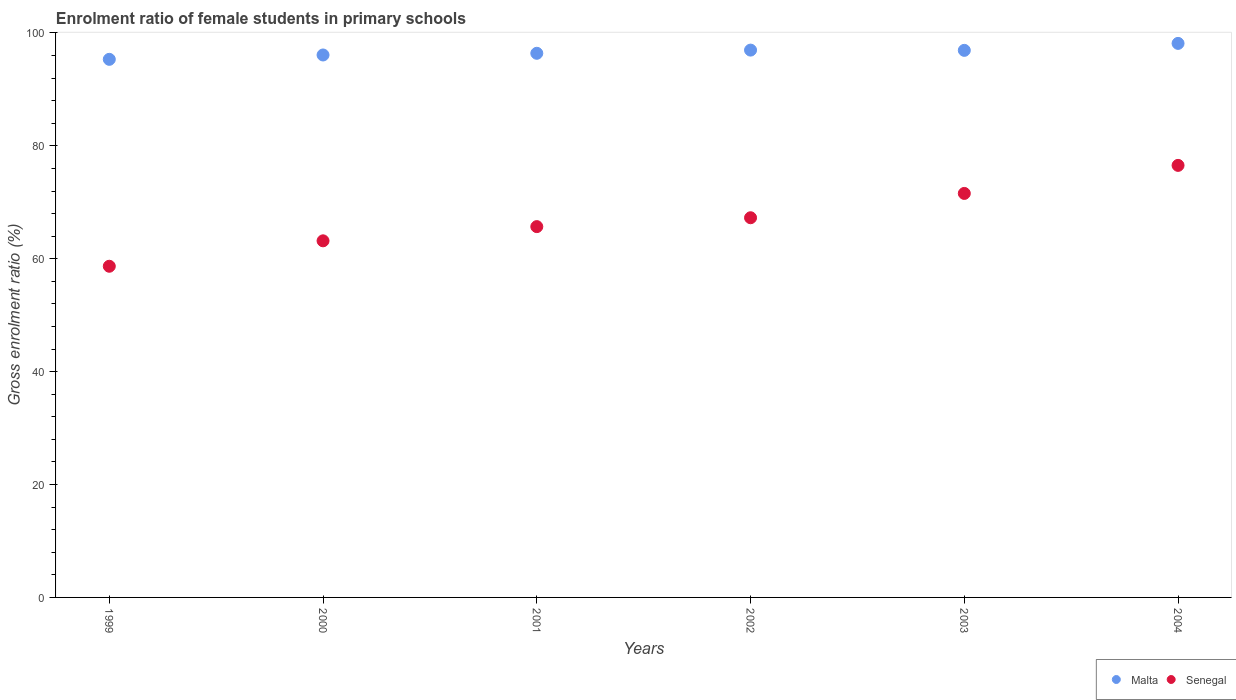Is the number of dotlines equal to the number of legend labels?
Your response must be concise. Yes. What is the enrolment ratio of female students in primary schools in Malta in 2002?
Your answer should be very brief. 96.96. Across all years, what is the maximum enrolment ratio of female students in primary schools in Malta?
Ensure brevity in your answer.  98.15. Across all years, what is the minimum enrolment ratio of female students in primary schools in Malta?
Ensure brevity in your answer.  95.33. In which year was the enrolment ratio of female students in primary schools in Malta minimum?
Offer a terse response. 1999. What is the total enrolment ratio of female students in primary schools in Malta in the graph?
Provide a succinct answer. 579.86. What is the difference between the enrolment ratio of female students in primary schools in Malta in 2002 and that in 2003?
Your response must be concise. 0.04. What is the difference between the enrolment ratio of female students in primary schools in Senegal in 2004 and the enrolment ratio of female students in primary schools in Malta in 1999?
Your answer should be very brief. -18.79. What is the average enrolment ratio of female students in primary schools in Senegal per year?
Provide a short and direct response. 67.15. In the year 2001, what is the difference between the enrolment ratio of female students in primary schools in Malta and enrolment ratio of female students in primary schools in Senegal?
Ensure brevity in your answer.  30.71. What is the ratio of the enrolment ratio of female students in primary schools in Senegal in 2002 to that in 2004?
Your answer should be very brief. 0.88. What is the difference between the highest and the second highest enrolment ratio of female students in primary schools in Malta?
Provide a short and direct response. 1.19. What is the difference between the highest and the lowest enrolment ratio of female students in primary schools in Malta?
Provide a short and direct response. 2.82. Is the sum of the enrolment ratio of female students in primary schools in Senegal in 1999 and 2002 greater than the maximum enrolment ratio of female students in primary schools in Malta across all years?
Ensure brevity in your answer.  Yes. Does the enrolment ratio of female students in primary schools in Senegal monotonically increase over the years?
Keep it short and to the point. Yes. Is the enrolment ratio of female students in primary schools in Senegal strictly less than the enrolment ratio of female students in primary schools in Malta over the years?
Give a very brief answer. Yes. How many years are there in the graph?
Make the answer very short. 6. Does the graph contain any zero values?
Give a very brief answer. No. Does the graph contain grids?
Offer a very short reply. No. Where does the legend appear in the graph?
Make the answer very short. Bottom right. How many legend labels are there?
Your response must be concise. 2. How are the legend labels stacked?
Provide a short and direct response. Horizontal. What is the title of the graph?
Keep it short and to the point. Enrolment ratio of female students in primary schools. Does "French Polynesia" appear as one of the legend labels in the graph?
Give a very brief answer. No. What is the label or title of the X-axis?
Keep it short and to the point. Years. What is the label or title of the Y-axis?
Your response must be concise. Gross enrolment ratio (%). What is the Gross enrolment ratio (%) of Malta in 1999?
Give a very brief answer. 95.33. What is the Gross enrolment ratio (%) in Senegal in 1999?
Give a very brief answer. 58.67. What is the Gross enrolment ratio (%) in Malta in 2000?
Your answer should be compact. 96.1. What is the Gross enrolment ratio (%) in Senegal in 2000?
Provide a short and direct response. 63.17. What is the Gross enrolment ratio (%) in Malta in 2001?
Make the answer very short. 96.4. What is the Gross enrolment ratio (%) of Senegal in 2001?
Keep it short and to the point. 65.69. What is the Gross enrolment ratio (%) of Malta in 2002?
Your answer should be very brief. 96.96. What is the Gross enrolment ratio (%) of Senegal in 2002?
Your response must be concise. 67.26. What is the Gross enrolment ratio (%) of Malta in 2003?
Your answer should be compact. 96.92. What is the Gross enrolment ratio (%) in Senegal in 2003?
Your response must be concise. 71.57. What is the Gross enrolment ratio (%) in Malta in 2004?
Offer a terse response. 98.15. What is the Gross enrolment ratio (%) in Senegal in 2004?
Keep it short and to the point. 76.54. Across all years, what is the maximum Gross enrolment ratio (%) in Malta?
Give a very brief answer. 98.15. Across all years, what is the maximum Gross enrolment ratio (%) in Senegal?
Provide a short and direct response. 76.54. Across all years, what is the minimum Gross enrolment ratio (%) of Malta?
Provide a short and direct response. 95.33. Across all years, what is the minimum Gross enrolment ratio (%) in Senegal?
Make the answer very short. 58.67. What is the total Gross enrolment ratio (%) of Malta in the graph?
Keep it short and to the point. 579.86. What is the total Gross enrolment ratio (%) of Senegal in the graph?
Make the answer very short. 402.91. What is the difference between the Gross enrolment ratio (%) of Malta in 1999 and that in 2000?
Ensure brevity in your answer.  -0.77. What is the difference between the Gross enrolment ratio (%) in Senegal in 1999 and that in 2000?
Your answer should be compact. -4.5. What is the difference between the Gross enrolment ratio (%) of Malta in 1999 and that in 2001?
Ensure brevity in your answer.  -1.07. What is the difference between the Gross enrolment ratio (%) in Senegal in 1999 and that in 2001?
Keep it short and to the point. -7.02. What is the difference between the Gross enrolment ratio (%) of Malta in 1999 and that in 2002?
Ensure brevity in your answer.  -1.63. What is the difference between the Gross enrolment ratio (%) in Senegal in 1999 and that in 2002?
Give a very brief answer. -8.59. What is the difference between the Gross enrolment ratio (%) in Malta in 1999 and that in 2003?
Provide a short and direct response. -1.59. What is the difference between the Gross enrolment ratio (%) of Senegal in 1999 and that in 2003?
Your answer should be compact. -12.9. What is the difference between the Gross enrolment ratio (%) in Malta in 1999 and that in 2004?
Your response must be concise. -2.82. What is the difference between the Gross enrolment ratio (%) in Senegal in 1999 and that in 2004?
Keep it short and to the point. -17.87. What is the difference between the Gross enrolment ratio (%) of Malta in 2000 and that in 2001?
Offer a very short reply. -0.3. What is the difference between the Gross enrolment ratio (%) of Senegal in 2000 and that in 2001?
Your answer should be compact. -2.52. What is the difference between the Gross enrolment ratio (%) of Malta in 2000 and that in 2002?
Provide a short and direct response. -0.86. What is the difference between the Gross enrolment ratio (%) in Senegal in 2000 and that in 2002?
Provide a short and direct response. -4.09. What is the difference between the Gross enrolment ratio (%) of Malta in 2000 and that in 2003?
Offer a terse response. -0.82. What is the difference between the Gross enrolment ratio (%) of Senegal in 2000 and that in 2003?
Provide a succinct answer. -8.4. What is the difference between the Gross enrolment ratio (%) of Malta in 2000 and that in 2004?
Offer a very short reply. -2.05. What is the difference between the Gross enrolment ratio (%) of Senegal in 2000 and that in 2004?
Make the answer very short. -13.37. What is the difference between the Gross enrolment ratio (%) of Malta in 2001 and that in 2002?
Provide a short and direct response. -0.56. What is the difference between the Gross enrolment ratio (%) in Senegal in 2001 and that in 2002?
Provide a short and direct response. -1.57. What is the difference between the Gross enrolment ratio (%) of Malta in 2001 and that in 2003?
Your answer should be compact. -0.52. What is the difference between the Gross enrolment ratio (%) of Senegal in 2001 and that in 2003?
Make the answer very short. -5.88. What is the difference between the Gross enrolment ratio (%) of Malta in 2001 and that in 2004?
Offer a very short reply. -1.75. What is the difference between the Gross enrolment ratio (%) in Senegal in 2001 and that in 2004?
Your answer should be compact. -10.85. What is the difference between the Gross enrolment ratio (%) in Malta in 2002 and that in 2003?
Your answer should be compact. 0.04. What is the difference between the Gross enrolment ratio (%) in Senegal in 2002 and that in 2003?
Your answer should be very brief. -4.31. What is the difference between the Gross enrolment ratio (%) in Malta in 2002 and that in 2004?
Your answer should be compact. -1.19. What is the difference between the Gross enrolment ratio (%) in Senegal in 2002 and that in 2004?
Offer a very short reply. -9.28. What is the difference between the Gross enrolment ratio (%) of Malta in 2003 and that in 2004?
Offer a very short reply. -1.23. What is the difference between the Gross enrolment ratio (%) of Senegal in 2003 and that in 2004?
Keep it short and to the point. -4.97. What is the difference between the Gross enrolment ratio (%) of Malta in 1999 and the Gross enrolment ratio (%) of Senegal in 2000?
Your response must be concise. 32.15. What is the difference between the Gross enrolment ratio (%) in Malta in 1999 and the Gross enrolment ratio (%) in Senegal in 2001?
Offer a very short reply. 29.64. What is the difference between the Gross enrolment ratio (%) in Malta in 1999 and the Gross enrolment ratio (%) in Senegal in 2002?
Give a very brief answer. 28.06. What is the difference between the Gross enrolment ratio (%) in Malta in 1999 and the Gross enrolment ratio (%) in Senegal in 2003?
Make the answer very short. 23.76. What is the difference between the Gross enrolment ratio (%) of Malta in 1999 and the Gross enrolment ratio (%) of Senegal in 2004?
Provide a succinct answer. 18.79. What is the difference between the Gross enrolment ratio (%) in Malta in 2000 and the Gross enrolment ratio (%) in Senegal in 2001?
Keep it short and to the point. 30.41. What is the difference between the Gross enrolment ratio (%) of Malta in 2000 and the Gross enrolment ratio (%) of Senegal in 2002?
Offer a terse response. 28.84. What is the difference between the Gross enrolment ratio (%) in Malta in 2000 and the Gross enrolment ratio (%) in Senegal in 2003?
Offer a terse response. 24.53. What is the difference between the Gross enrolment ratio (%) of Malta in 2000 and the Gross enrolment ratio (%) of Senegal in 2004?
Your answer should be very brief. 19.56. What is the difference between the Gross enrolment ratio (%) of Malta in 2001 and the Gross enrolment ratio (%) of Senegal in 2002?
Keep it short and to the point. 29.14. What is the difference between the Gross enrolment ratio (%) of Malta in 2001 and the Gross enrolment ratio (%) of Senegal in 2003?
Keep it short and to the point. 24.83. What is the difference between the Gross enrolment ratio (%) in Malta in 2001 and the Gross enrolment ratio (%) in Senegal in 2004?
Make the answer very short. 19.86. What is the difference between the Gross enrolment ratio (%) in Malta in 2002 and the Gross enrolment ratio (%) in Senegal in 2003?
Offer a very short reply. 25.39. What is the difference between the Gross enrolment ratio (%) of Malta in 2002 and the Gross enrolment ratio (%) of Senegal in 2004?
Offer a terse response. 20.42. What is the difference between the Gross enrolment ratio (%) of Malta in 2003 and the Gross enrolment ratio (%) of Senegal in 2004?
Keep it short and to the point. 20.38. What is the average Gross enrolment ratio (%) in Malta per year?
Provide a short and direct response. 96.64. What is the average Gross enrolment ratio (%) in Senegal per year?
Offer a terse response. 67.15. In the year 1999, what is the difference between the Gross enrolment ratio (%) of Malta and Gross enrolment ratio (%) of Senegal?
Give a very brief answer. 36.66. In the year 2000, what is the difference between the Gross enrolment ratio (%) in Malta and Gross enrolment ratio (%) in Senegal?
Keep it short and to the point. 32.92. In the year 2001, what is the difference between the Gross enrolment ratio (%) of Malta and Gross enrolment ratio (%) of Senegal?
Keep it short and to the point. 30.71. In the year 2002, what is the difference between the Gross enrolment ratio (%) in Malta and Gross enrolment ratio (%) in Senegal?
Provide a short and direct response. 29.7. In the year 2003, what is the difference between the Gross enrolment ratio (%) in Malta and Gross enrolment ratio (%) in Senegal?
Your answer should be compact. 25.35. In the year 2004, what is the difference between the Gross enrolment ratio (%) of Malta and Gross enrolment ratio (%) of Senegal?
Your answer should be very brief. 21.61. What is the ratio of the Gross enrolment ratio (%) of Malta in 1999 to that in 2000?
Your response must be concise. 0.99. What is the ratio of the Gross enrolment ratio (%) of Senegal in 1999 to that in 2000?
Provide a succinct answer. 0.93. What is the ratio of the Gross enrolment ratio (%) of Malta in 1999 to that in 2001?
Provide a succinct answer. 0.99. What is the ratio of the Gross enrolment ratio (%) of Senegal in 1999 to that in 2001?
Make the answer very short. 0.89. What is the ratio of the Gross enrolment ratio (%) of Malta in 1999 to that in 2002?
Your response must be concise. 0.98. What is the ratio of the Gross enrolment ratio (%) in Senegal in 1999 to that in 2002?
Keep it short and to the point. 0.87. What is the ratio of the Gross enrolment ratio (%) of Malta in 1999 to that in 2003?
Your response must be concise. 0.98. What is the ratio of the Gross enrolment ratio (%) in Senegal in 1999 to that in 2003?
Keep it short and to the point. 0.82. What is the ratio of the Gross enrolment ratio (%) in Malta in 1999 to that in 2004?
Make the answer very short. 0.97. What is the ratio of the Gross enrolment ratio (%) in Senegal in 1999 to that in 2004?
Your answer should be compact. 0.77. What is the ratio of the Gross enrolment ratio (%) in Senegal in 2000 to that in 2001?
Provide a short and direct response. 0.96. What is the ratio of the Gross enrolment ratio (%) of Senegal in 2000 to that in 2002?
Your answer should be very brief. 0.94. What is the ratio of the Gross enrolment ratio (%) in Senegal in 2000 to that in 2003?
Make the answer very short. 0.88. What is the ratio of the Gross enrolment ratio (%) in Malta in 2000 to that in 2004?
Offer a very short reply. 0.98. What is the ratio of the Gross enrolment ratio (%) in Senegal in 2000 to that in 2004?
Make the answer very short. 0.83. What is the ratio of the Gross enrolment ratio (%) of Malta in 2001 to that in 2002?
Give a very brief answer. 0.99. What is the ratio of the Gross enrolment ratio (%) in Senegal in 2001 to that in 2002?
Ensure brevity in your answer.  0.98. What is the ratio of the Gross enrolment ratio (%) of Malta in 2001 to that in 2003?
Your answer should be very brief. 0.99. What is the ratio of the Gross enrolment ratio (%) in Senegal in 2001 to that in 2003?
Your response must be concise. 0.92. What is the ratio of the Gross enrolment ratio (%) of Malta in 2001 to that in 2004?
Your answer should be compact. 0.98. What is the ratio of the Gross enrolment ratio (%) of Senegal in 2001 to that in 2004?
Offer a very short reply. 0.86. What is the ratio of the Gross enrolment ratio (%) in Senegal in 2002 to that in 2003?
Provide a succinct answer. 0.94. What is the ratio of the Gross enrolment ratio (%) of Malta in 2002 to that in 2004?
Provide a succinct answer. 0.99. What is the ratio of the Gross enrolment ratio (%) in Senegal in 2002 to that in 2004?
Your response must be concise. 0.88. What is the ratio of the Gross enrolment ratio (%) of Malta in 2003 to that in 2004?
Offer a terse response. 0.99. What is the ratio of the Gross enrolment ratio (%) in Senegal in 2003 to that in 2004?
Offer a terse response. 0.94. What is the difference between the highest and the second highest Gross enrolment ratio (%) in Malta?
Give a very brief answer. 1.19. What is the difference between the highest and the second highest Gross enrolment ratio (%) in Senegal?
Offer a very short reply. 4.97. What is the difference between the highest and the lowest Gross enrolment ratio (%) in Malta?
Your answer should be very brief. 2.82. What is the difference between the highest and the lowest Gross enrolment ratio (%) in Senegal?
Make the answer very short. 17.87. 